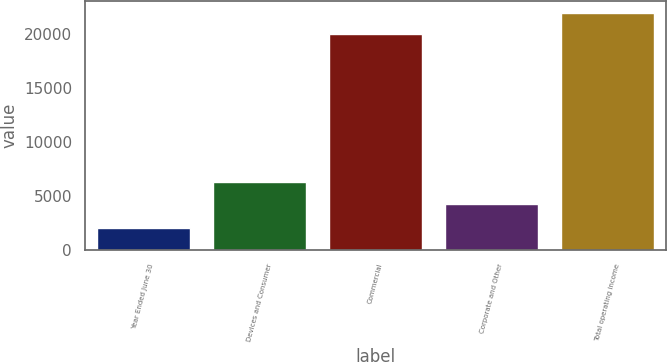Convert chart to OTSL. <chart><loc_0><loc_0><loc_500><loc_500><bar_chart><fcel>Year Ended June 30<fcel>Devices and Consumer<fcel>Commercial<fcel>Corporate and Other<fcel>Total operating income<nl><fcel>2012<fcel>6241.1<fcel>19978<fcel>4266<fcel>21953.1<nl></chart> 